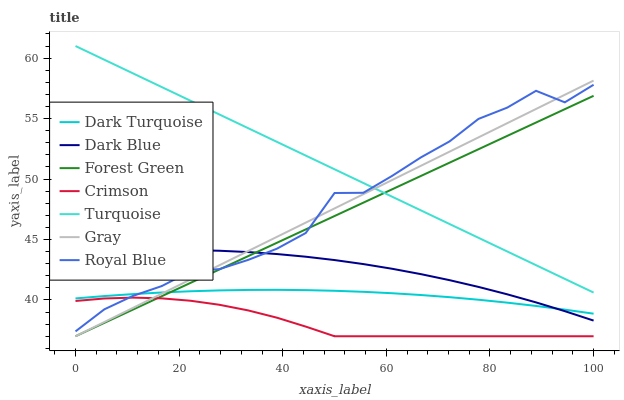Does Crimson have the minimum area under the curve?
Answer yes or no. Yes. Does Turquoise have the maximum area under the curve?
Answer yes or no. Yes. Does Royal Blue have the minimum area under the curve?
Answer yes or no. No. Does Royal Blue have the maximum area under the curve?
Answer yes or no. No. Is Gray the smoothest?
Answer yes or no. Yes. Is Royal Blue the roughest?
Answer yes or no. Yes. Is Turquoise the smoothest?
Answer yes or no. No. Is Turquoise the roughest?
Answer yes or no. No. Does Gray have the lowest value?
Answer yes or no. Yes. Does Royal Blue have the lowest value?
Answer yes or no. No. Does Turquoise have the highest value?
Answer yes or no. Yes. Does Royal Blue have the highest value?
Answer yes or no. No. Is Crimson less than Dark Blue?
Answer yes or no. Yes. Is Turquoise greater than Dark Turquoise?
Answer yes or no. Yes. Does Dark Blue intersect Forest Green?
Answer yes or no. Yes. Is Dark Blue less than Forest Green?
Answer yes or no. No. Is Dark Blue greater than Forest Green?
Answer yes or no. No. Does Crimson intersect Dark Blue?
Answer yes or no. No. 